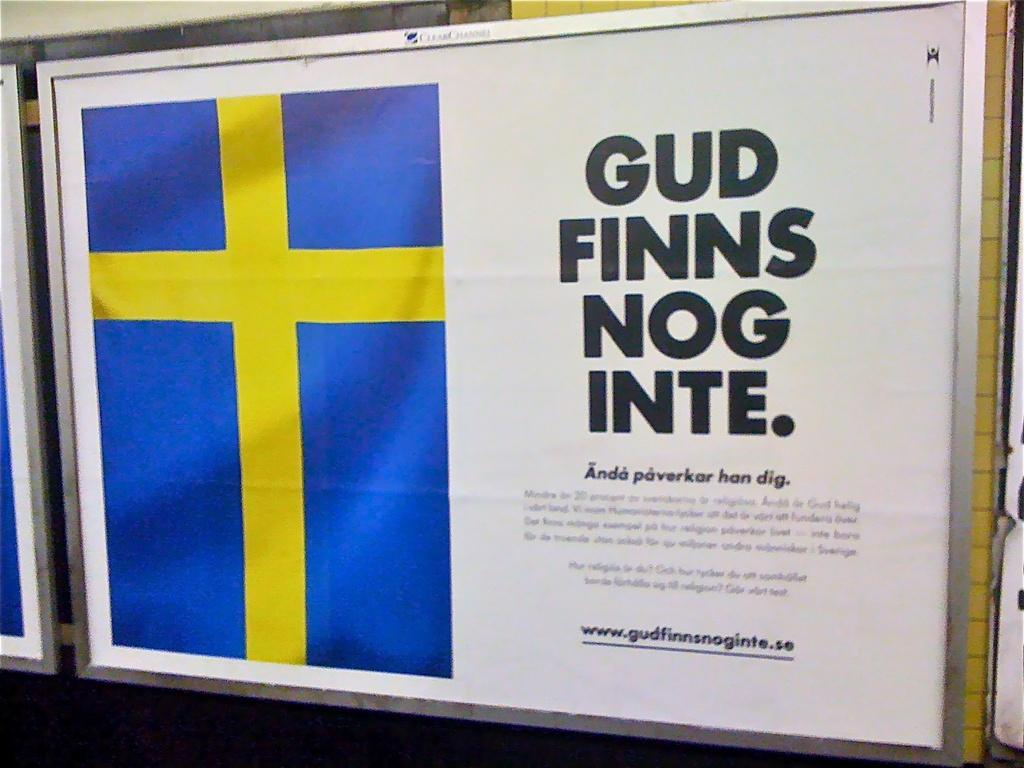<image>
Summarize the visual content of the image. Paper that says Gud Finns Nog inte and a flag on the left. 